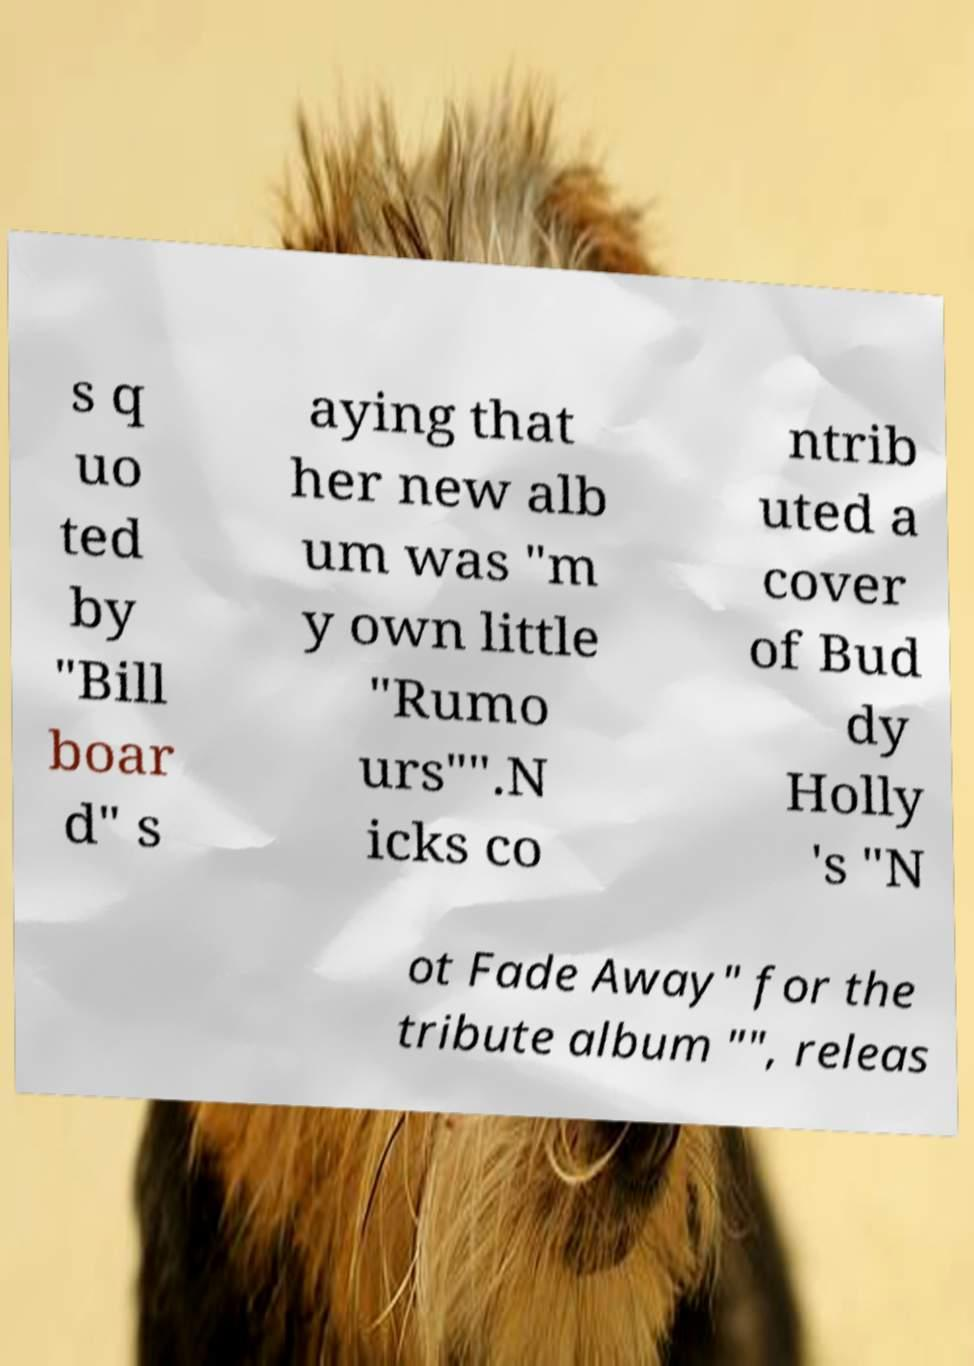I need the written content from this picture converted into text. Can you do that? s q uo ted by "Bill boar d" s aying that her new alb um was "m y own little "Rumo urs"".N icks co ntrib uted a cover of Bud dy Holly 's "N ot Fade Away" for the tribute album "", releas 